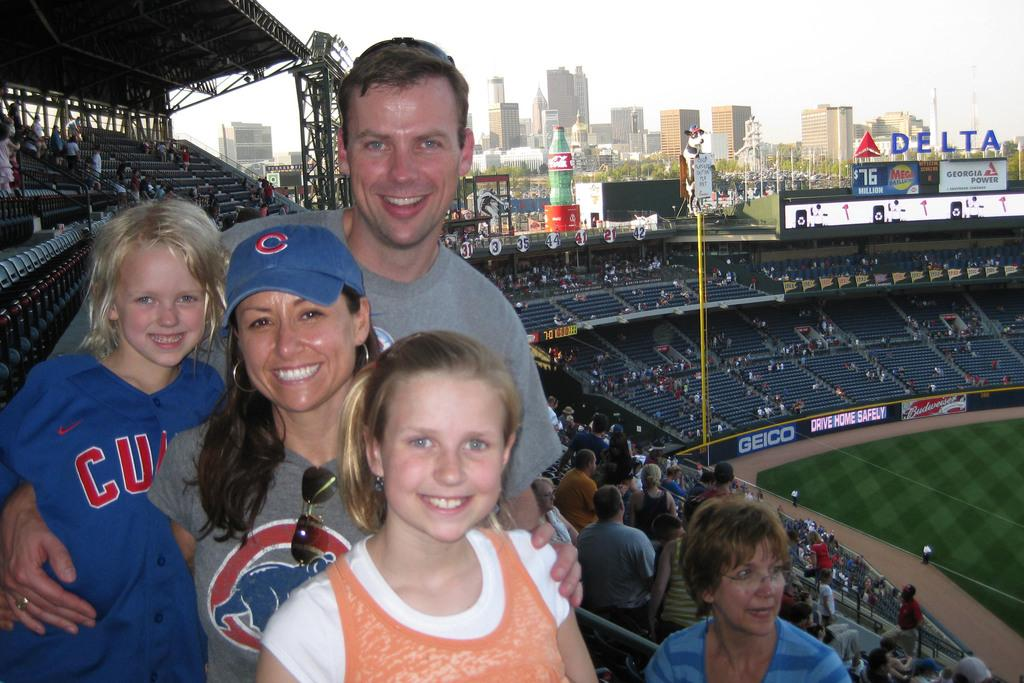Provide a one-sentence caption for the provided image. a family with a little girl wearing a 'cubs' jersey. 